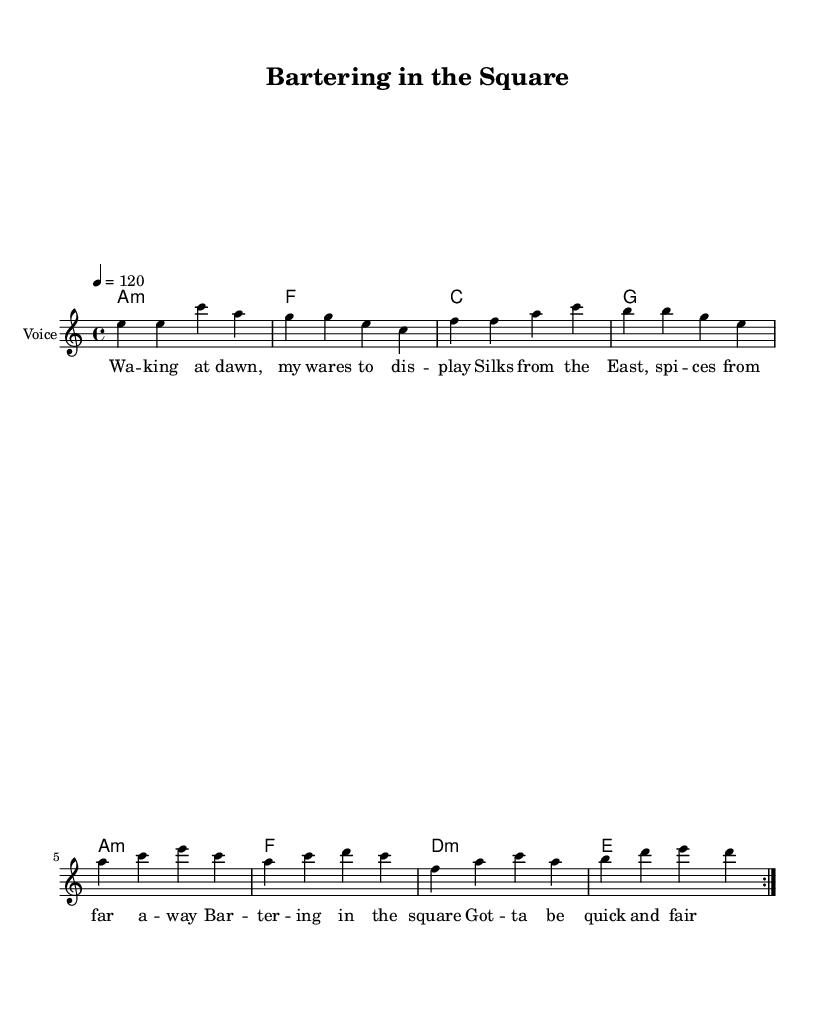What is the key signature of this music? The key signature is A minor, which has no sharps or flats. This can be identified in the global section of the sheet music which defines the key setting.
Answer: A minor What is the time signature in this piece? The time signature is indicated as 4/4 in the global section. This means there are four beats in each measure, and each quarter note gets one beat.
Answer: 4/4 What is the tempo marking provided? The tempo is marked as 120 beats per minute, which is noted in the global section. This indicates the speed at which the music should be played.
Answer: 120 How many measures are repeated in the melody? The melody includes a repeat sign indicating that the preceding measures (two measures of music) should be played again, which is explicitly shown with the repeat volta notation.
Answer: 2 What type of musical piece is this? This piece is categorized as Rhythm and Blues due to its structure, upbeat tempo, and themes regarding daily life and challenges of merchants, which align with the characteristics of this genre.
Answer: Rhythm and Blues Which chords are used in the harmonies? The chord progression in the harmonies consists of A minor, F, C, G, A minor, F, D minor, and E. These chords provide the harmonic support for the melody.
Answer: A minor, F, C, G, D minor, E What is the focus of the lyrics in this piece? The lyrics focus on the daily activities and challenges faced by merchants in a bustling medieval marketplace, reflecting their experiences of bartering and trading goods.
Answer: Merchants 